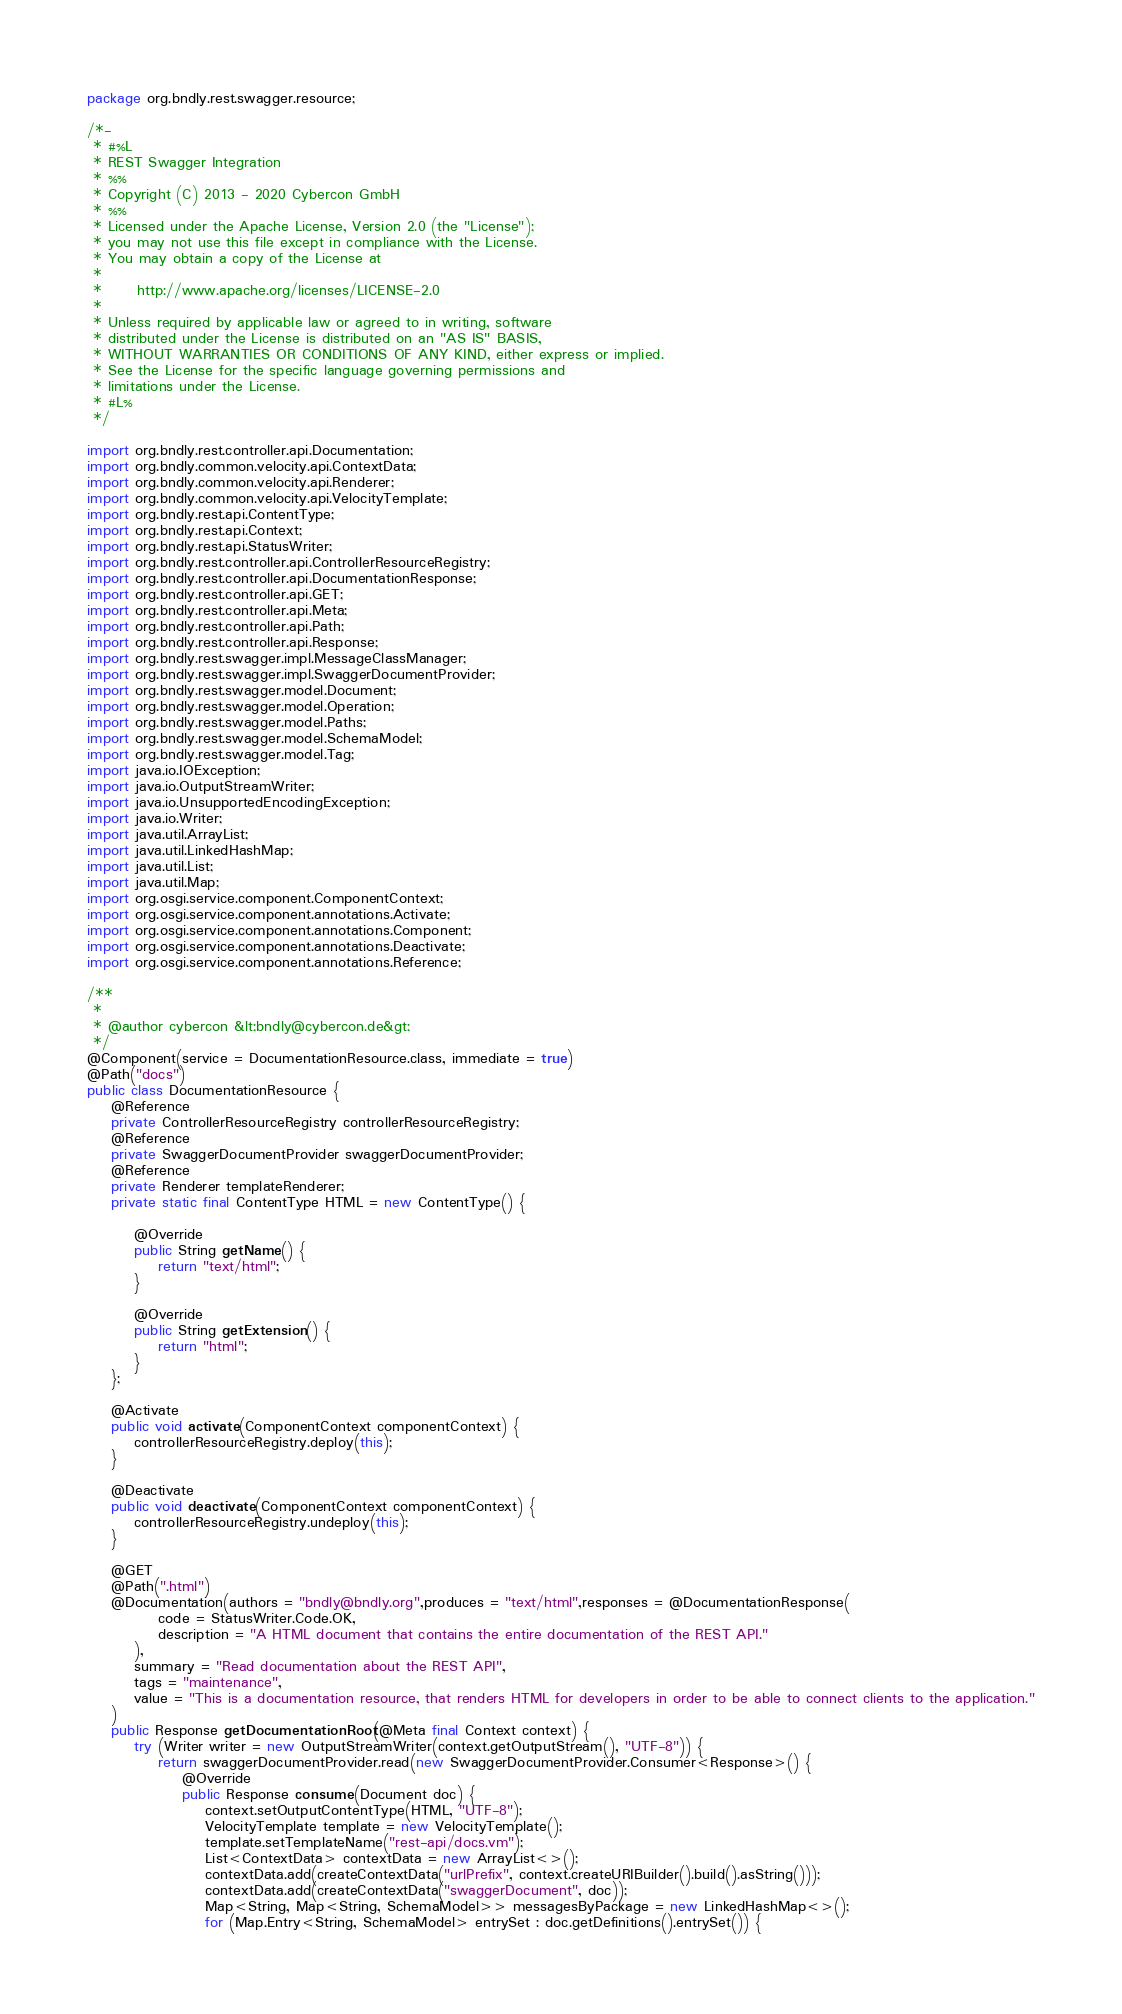<code> <loc_0><loc_0><loc_500><loc_500><_Java_>package org.bndly.rest.swagger.resource;

/*-
 * #%L
 * REST Swagger Integration
 * %%
 * Copyright (C) 2013 - 2020 Cybercon GmbH
 * %%
 * Licensed under the Apache License, Version 2.0 (the "License");
 * you may not use this file except in compliance with the License.
 * You may obtain a copy of the License at
 * 
 *      http://www.apache.org/licenses/LICENSE-2.0
 * 
 * Unless required by applicable law or agreed to in writing, software
 * distributed under the License is distributed on an "AS IS" BASIS,
 * WITHOUT WARRANTIES OR CONDITIONS OF ANY KIND, either express or implied.
 * See the License for the specific language governing permissions and
 * limitations under the License.
 * #L%
 */

import org.bndly.rest.controller.api.Documentation;
import org.bndly.common.velocity.api.ContextData;
import org.bndly.common.velocity.api.Renderer;
import org.bndly.common.velocity.api.VelocityTemplate;
import org.bndly.rest.api.ContentType;
import org.bndly.rest.api.Context;
import org.bndly.rest.api.StatusWriter;
import org.bndly.rest.controller.api.ControllerResourceRegistry;
import org.bndly.rest.controller.api.DocumentationResponse;
import org.bndly.rest.controller.api.GET;
import org.bndly.rest.controller.api.Meta;
import org.bndly.rest.controller.api.Path;
import org.bndly.rest.controller.api.Response;
import org.bndly.rest.swagger.impl.MessageClassManager;
import org.bndly.rest.swagger.impl.SwaggerDocumentProvider;
import org.bndly.rest.swagger.model.Document;
import org.bndly.rest.swagger.model.Operation;
import org.bndly.rest.swagger.model.Paths;
import org.bndly.rest.swagger.model.SchemaModel;
import org.bndly.rest.swagger.model.Tag;
import java.io.IOException;
import java.io.OutputStreamWriter;
import java.io.UnsupportedEncodingException;
import java.io.Writer;
import java.util.ArrayList;
import java.util.LinkedHashMap;
import java.util.List;
import java.util.Map;
import org.osgi.service.component.ComponentContext;
import org.osgi.service.component.annotations.Activate;
import org.osgi.service.component.annotations.Component;
import org.osgi.service.component.annotations.Deactivate;
import org.osgi.service.component.annotations.Reference;

/**
 *
 * @author cybercon &lt;bndly@cybercon.de&gt;
 */
@Component(service = DocumentationResource.class, immediate = true)
@Path("docs")
public class DocumentationResource {
	@Reference
	private ControllerResourceRegistry controllerResourceRegistry;
	@Reference
	private SwaggerDocumentProvider swaggerDocumentProvider;
	@Reference
	private Renderer templateRenderer;
	private static final ContentType HTML = new ContentType() {

		@Override
		public String getName() {
			return "text/html";
		}

		@Override
		public String getExtension() {
			return "html";
		}
	};
	
	@Activate
	public void activate(ComponentContext componentContext) {
		controllerResourceRegistry.deploy(this);
	}

	@Deactivate
	public void deactivate(ComponentContext componentContext) {
		controllerResourceRegistry.undeploy(this);
	}
	
	@GET
	@Path(".html")
	@Documentation(authors = "bndly@bndly.org",produces = "text/html",responses = @DocumentationResponse(
			code = StatusWriter.Code.OK,
			description = "A HTML document that contains the entire documentation of the REST API."
		), 
		summary = "Read documentation about the REST API", 
		tags = "maintenance", 
		value = "This is a documentation resource, that renders HTML for developers in order to be able to connect clients to the application."
	)
	public Response getDocumentationRoot(@Meta final Context context) {
		try (Writer writer = new OutputStreamWriter(context.getOutputStream(), "UTF-8")) {
			return swaggerDocumentProvider.read(new SwaggerDocumentProvider.Consumer<Response>() {
				@Override
				public Response consume(Document doc) {
					context.setOutputContentType(HTML, "UTF-8");
					VelocityTemplate template = new VelocityTemplate();
					template.setTemplateName("rest-api/docs.vm");
					List<ContextData> contextData = new ArrayList<>();
					contextData.add(createContextData("urlPrefix", context.createURIBuilder().build().asString()));
					contextData.add(createContextData("swaggerDocument", doc));
					Map<String, Map<String, SchemaModel>> messagesByPackage = new LinkedHashMap<>();
					for (Map.Entry<String, SchemaModel> entrySet : doc.getDefinitions().entrySet()) {</code> 